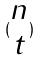<formula> <loc_0><loc_0><loc_500><loc_500>( \begin{matrix} n \\ t \end{matrix} )</formula> 